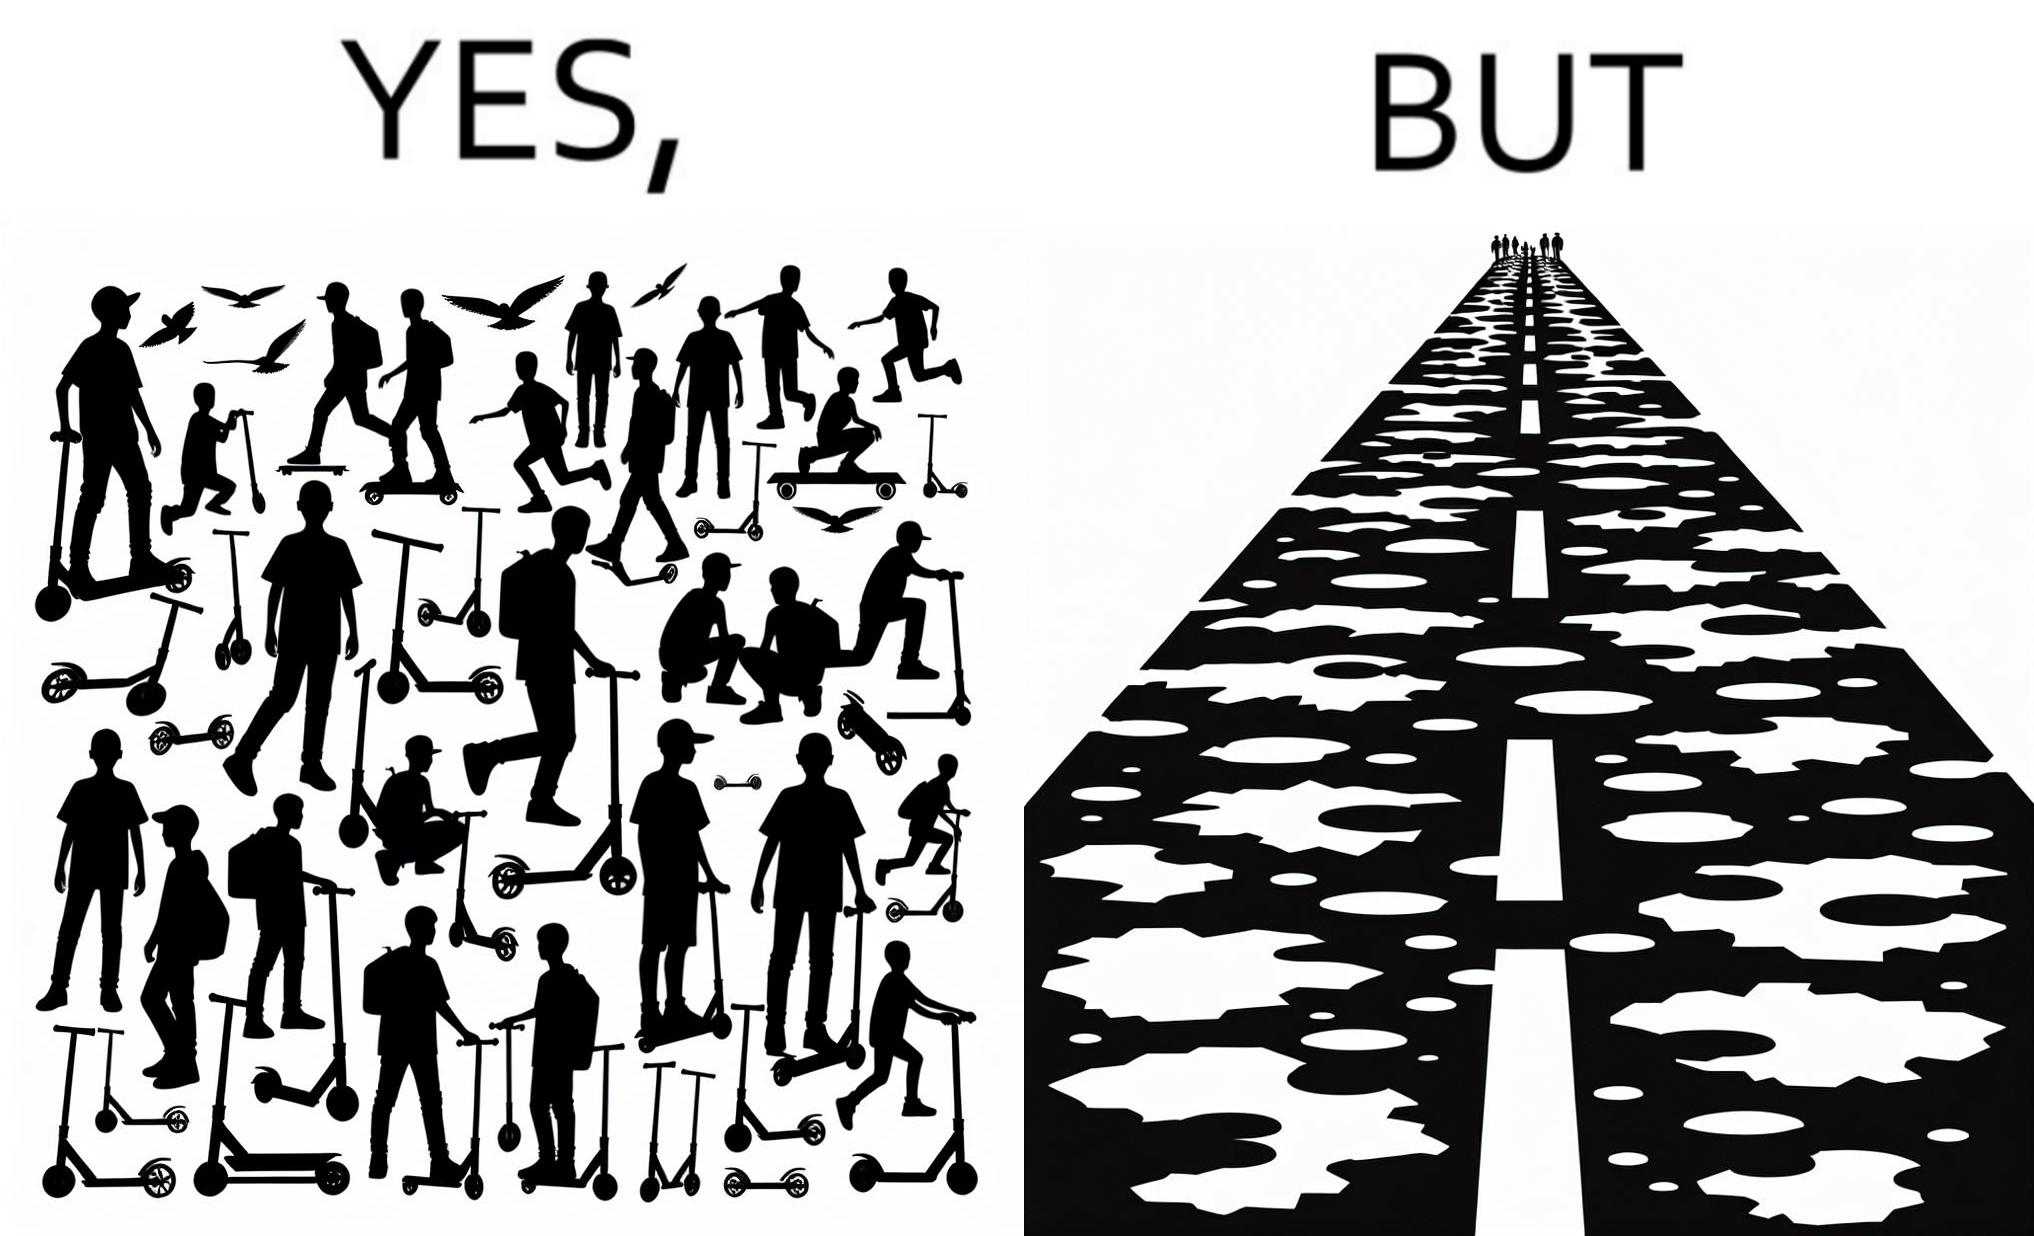Describe the contrast between the left and right parts of this image. In the left part of the image: many skateboard scooters parked together In the right part of the image: a straight road with many potholes 